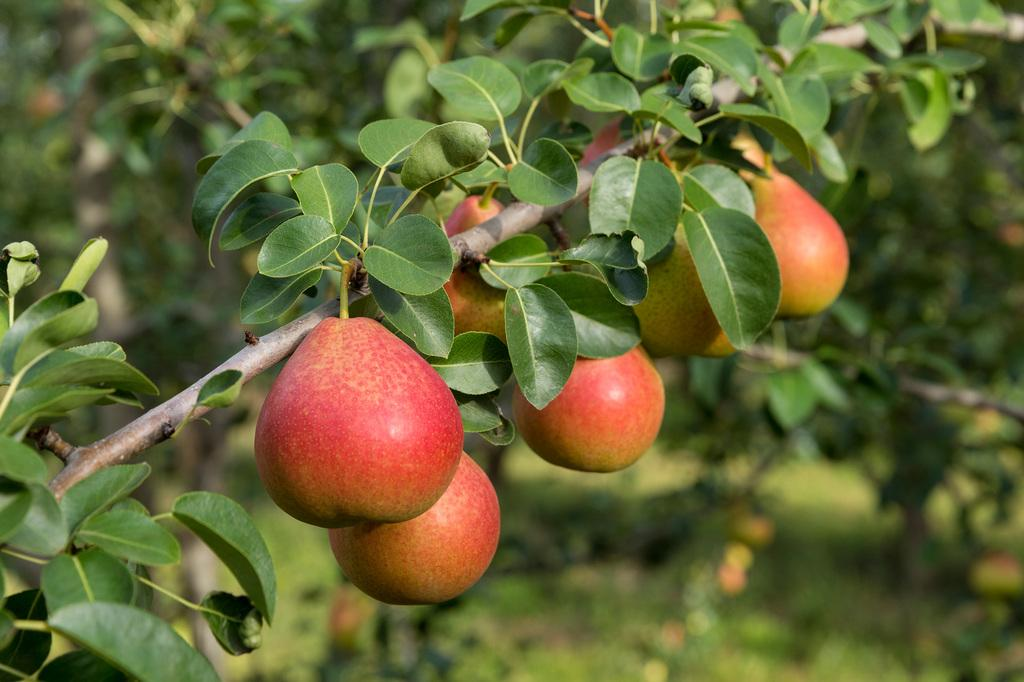What type of food can be seen in the image? There are fruits in the image. What else is present in the image besides the fruits? There are leaves visible in the image. What can be seen in the background of the image? There are trees visible in the background of the image. How would you describe the background of the image? The background is blurry. Are there any cows reading books in the image? There are no cows or books present in the image. 